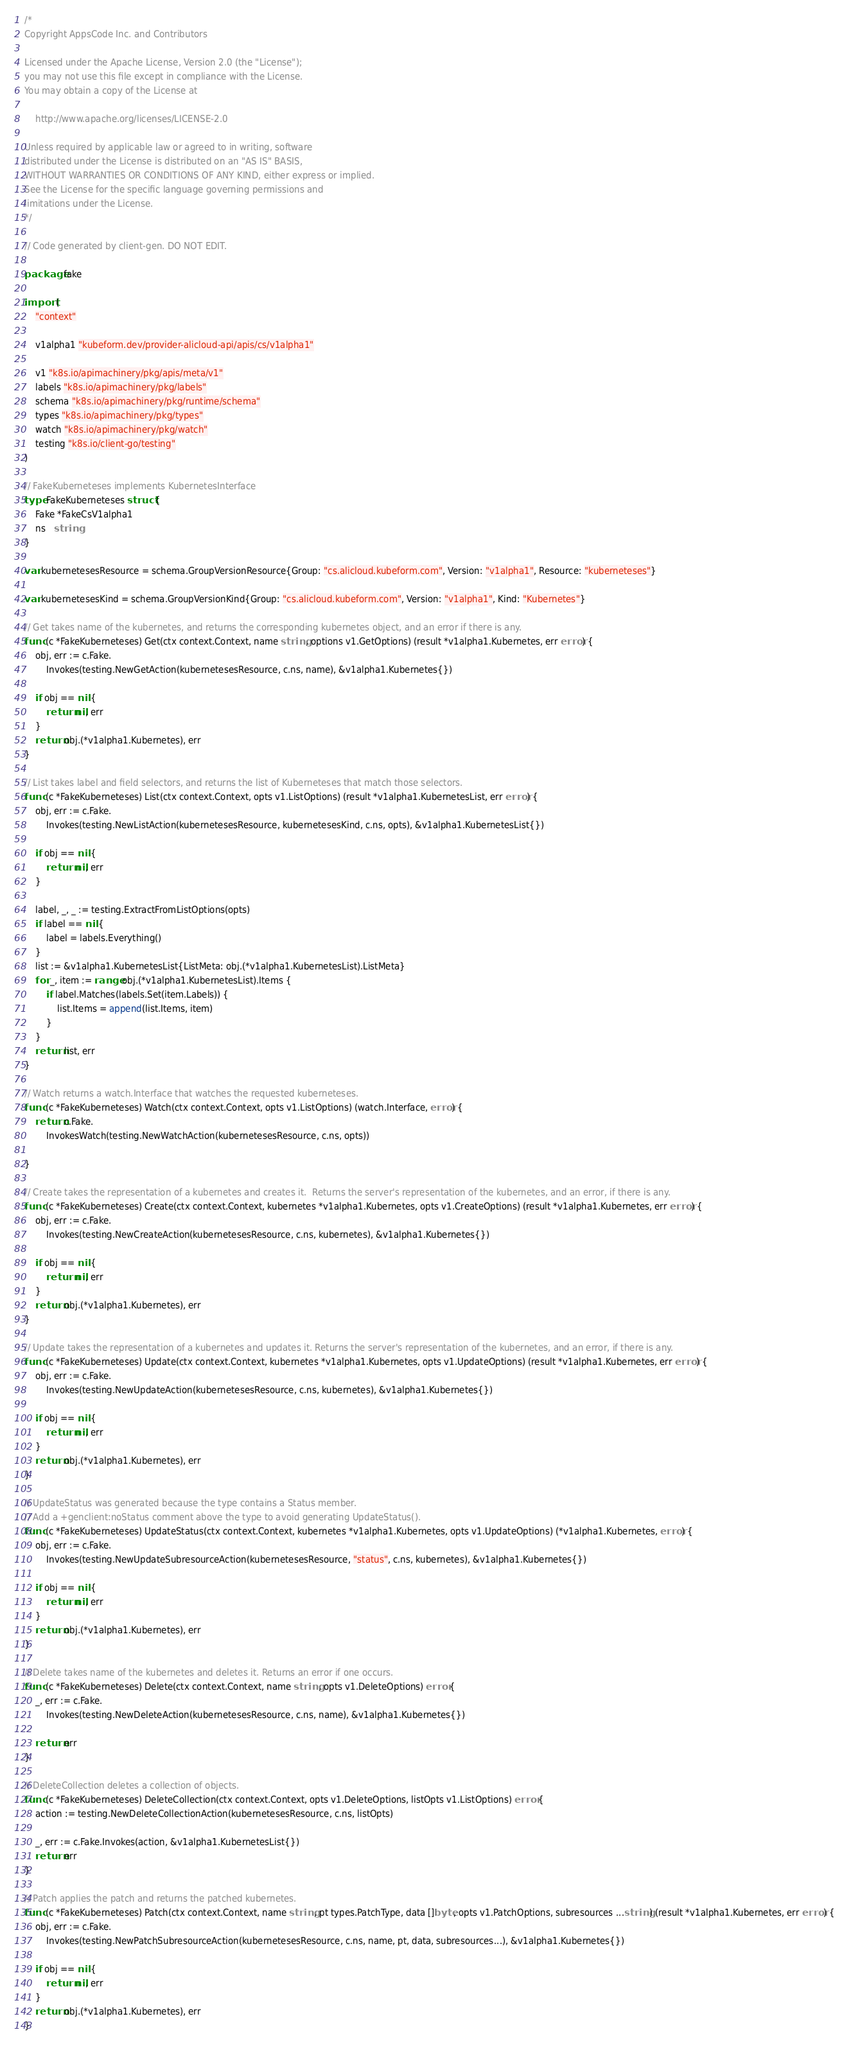<code> <loc_0><loc_0><loc_500><loc_500><_Go_>/*
Copyright AppsCode Inc. and Contributors

Licensed under the Apache License, Version 2.0 (the "License");
you may not use this file except in compliance with the License.
You may obtain a copy of the License at

    http://www.apache.org/licenses/LICENSE-2.0

Unless required by applicable law or agreed to in writing, software
distributed under the License is distributed on an "AS IS" BASIS,
WITHOUT WARRANTIES OR CONDITIONS OF ANY KIND, either express or implied.
See the License for the specific language governing permissions and
limitations under the License.
*/

// Code generated by client-gen. DO NOT EDIT.

package fake

import (
	"context"

	v1alpha1 "kubeform.dev/provider-alicloud-api/apis/cs/v1alpha1"

	v1 "k8s.io/apimachinery/pkg/apis/meta/v1"
	labels "k8s.io/apimachinery/pkg/labels"
	schema "k8s.io/apimachinery/pkg/runtime/schema"
	types "k8s.io/apimachinery/pkg/types"
	watch "k8s.io/apimachinery/pkg/watch"
	testing "k8s.io/client-go/testing"
)

// FakeKuberneteses implements KubernetesInterface
type FakeKuberneteses struct {
	Fake *FakeCsV1alpha1
	ns   string
}

var kubernetesesResource = schema.GroupVersionResource{Group: "cs.alicloud.kubeform.com", Version: "v1alpha1", Resource: "kuberneteses"}

var kubernetesesKind = schema.GroupVersionKind{Group: "cs.alicloud.kubeform.com", Version: "v1alpha1", Kind: "Kubernetes"}

// Get takes name of the kubernetes, and returns the corresponding kubernetes object, and an error if there is any.
func (c *FakeKuberneteses) Get(ctx context.Context, name string, options v1.GetOptions) (result *v1alpha1.Kubernetes, err error) {
	obj, err := c.Fake.
		Invokes(testing.NewGetAction(kubernetesesResource, c.ns, name), &v1alpha1.Kubernetes{})

	if obj == nil {
		return nil, err
	}
	return obj.(*v1alpha1.Kubernetes), err
}

// List takes label and field selectors, and returns the list of Kuberneteses that match those selectors.
func (c *FakeKuberneteses) List(ctx context.Context, opts v1.ListOptions) (result *v1alpha1.KubernetesList, err error) {
	obj, err := c.Fake.
		Invokes(testing.NewListAction(kubernetesesResource, kubernetesesKind, c.ns, opts), &v1alpha1.KubernetesList{})

	if obj == nil {
		return nil, err
	}

	label, _, _ := testing.ExtractFromListOptions(opts)
	if label == nil {
		label = labels.Everything()
	}
	list := &v1alpha1.KubernetesList{ListMeta: obj.(*v1alpha1.KubernetesList).ListMeta}
	for _, item := range obj.(*v1alpha1.KubernetesList).Items {
		if label.Matches(labels.Set(item.Labels)) {
			list.Items = append(list.Items, item)
		}
	}
	return list, err
}

// Watch returns a watch.Interface that watches the requested kuberneteses.
func (c *FakeKuberneteses) Watch(ctx context.Context, opts v1.ListOptions) (watch.Interface, error) {
	return c.Fake.
		InvokesWatch(testing.NewWatchAction(kubernetesesResource, c.ns, opts))

}

// Create takes the representation of a kubernetes and creates it.  Returns the server's representation of the kubernetes, and an error, if there is any.
func (c *FakeKuberneteses) Create(ctx context.Context, kubernetes *v1alpha1.Kubernetes, opts v1.CreateOptions) (result *v1alpha1.Kubernetes, err error) {
	obj, err := c.Fake.
		Invokes(testing.NewCreateAction(kubernetesesResource, c.ns, kubernetes), &v1alpha1.Kubernetes{})

	if obj == nil {
		return nil, err
	}
	return obj.(*v1alpha1.Kubernetes), err
}

// Update takes the representation of a kubernetes and updates it. Returns the server's representation of the kubernetes, and an error, if there is any.
func (c *FakeKuberneteses) Update(ctx context.Context, kubernetes *v1alpha1.Kubernetes, opts v1.UpdateOptions) (result *v1alpha1.Kubernetes, err error) {
	obj, err := c.Fake.
		Invokes(testing.NewUpdateAction(kubernetesesResource, c.ns, kubernetes), &v1alpha1.Kubernetes{})

	if obj == nil {
		return nil, err
	}
	return obj.(*v1alpha1.Kubernetes), err
}

// UpdateStatus was generated because the type contains a Status member.
// Add a +genclient:noStatus comment above the type to avoid generating UpdateStatus().
func (c *FakeKuberneteses) UpdateStatus(ctx context.Context, kubernetes *v1alpha1.Kubernetes, opts v1.UpdateOptions) (*v1alpha1.Kubernetes, error) {
	obj, err := c.Fake.
		Invokes(testing.NewUpdateSubresourceAction(kubernetesesResource, "status", c.ns, kubernetes), &v1alpha1.Kubernetes{})

	if obj == nil {
		return nil, err
	}
	return obj.(*v1alpha1.Kubernetes), err
}

// Delete takes name of the kubernetes and deletes it. Returns an error if one occurs.
func (c *FakeKuberneteses) Delete(ctx context.Context, name string, opts v1.DeleteOptions) error {
	_, err := c.Fake.
		Invokes(testing.NewDeleteAction(kubernetesesResource, c.ns, name), &v1alpha1.Kubernetes{})

	return err
}

// DeleteCollection deletes a collection of objects.
func (c *FakeKuberneteses) DeleteCollection(ctx context.Context, opts v1.DeleteOptions, listOpts v1.ListOptions) error {
	action := testing.NewDeleteCollectionAction(kubernetesesResource, c.ns, listOpts)

	_, err := c.Fake.Invokes(action, &v1alpha1.KubernetesList{})
	return err
}

// Patch applies the patch and returns the patched kubernetes.
func (c *FakeKuberneteses) Patch(ctx context.Context, name string, pt types.PatchType, data []byte, opts v1.PatchOptions, subresources ...string) (result *v1alpha1.Kubernetes, err error) {
	obj, err := c.Fake.
		Invokes(testing.NewPatchSubresourceAction(kubernetesesResource, c.ns, name, pt, data, subresources...), &v1alpha1.Kubernetes{})

	if obj == nil {
		return nil, err
	}
	return obj.(*v1alpha1.Kubernetes), err
}
</code> 